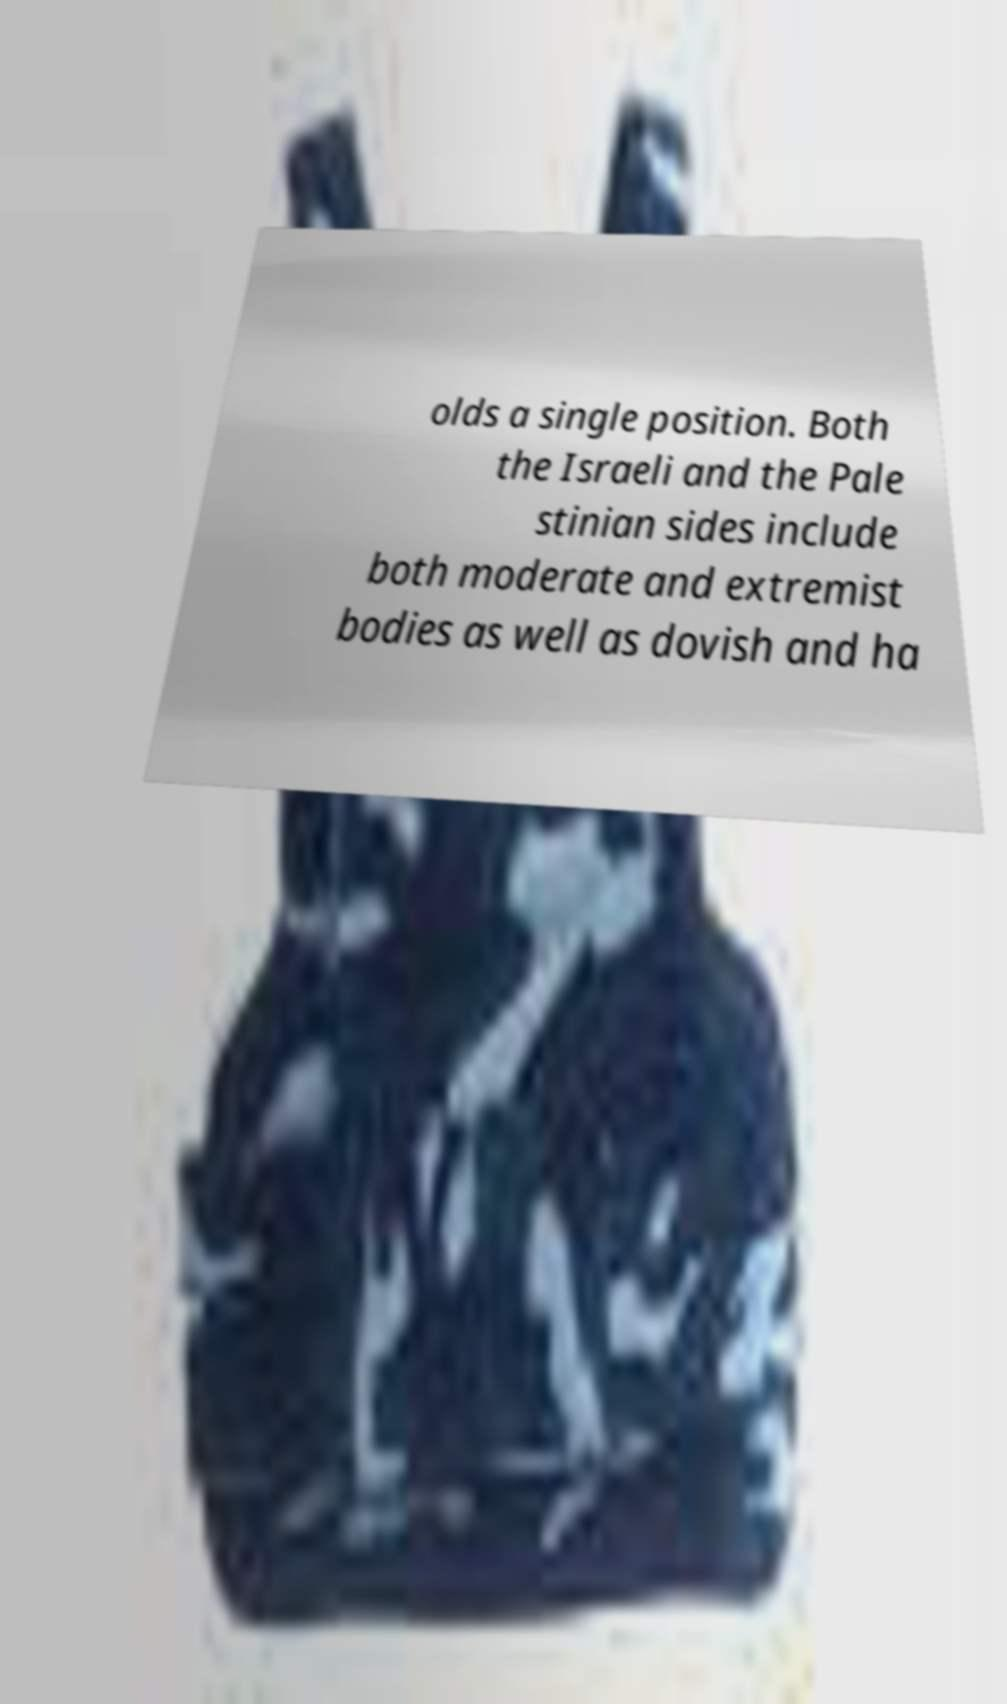Could you extract and type out the text from this image? olds a single position. Both the Israeli and the Pale stinian sides include both moderate and extremist bodies as well as dovish and ha 